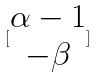<formula> <loc_0><loc_0><loc_500><loc_500>[ \begin{matrix} \alpha - 1 \\ - \beta \end{matrix} ]</formula> 